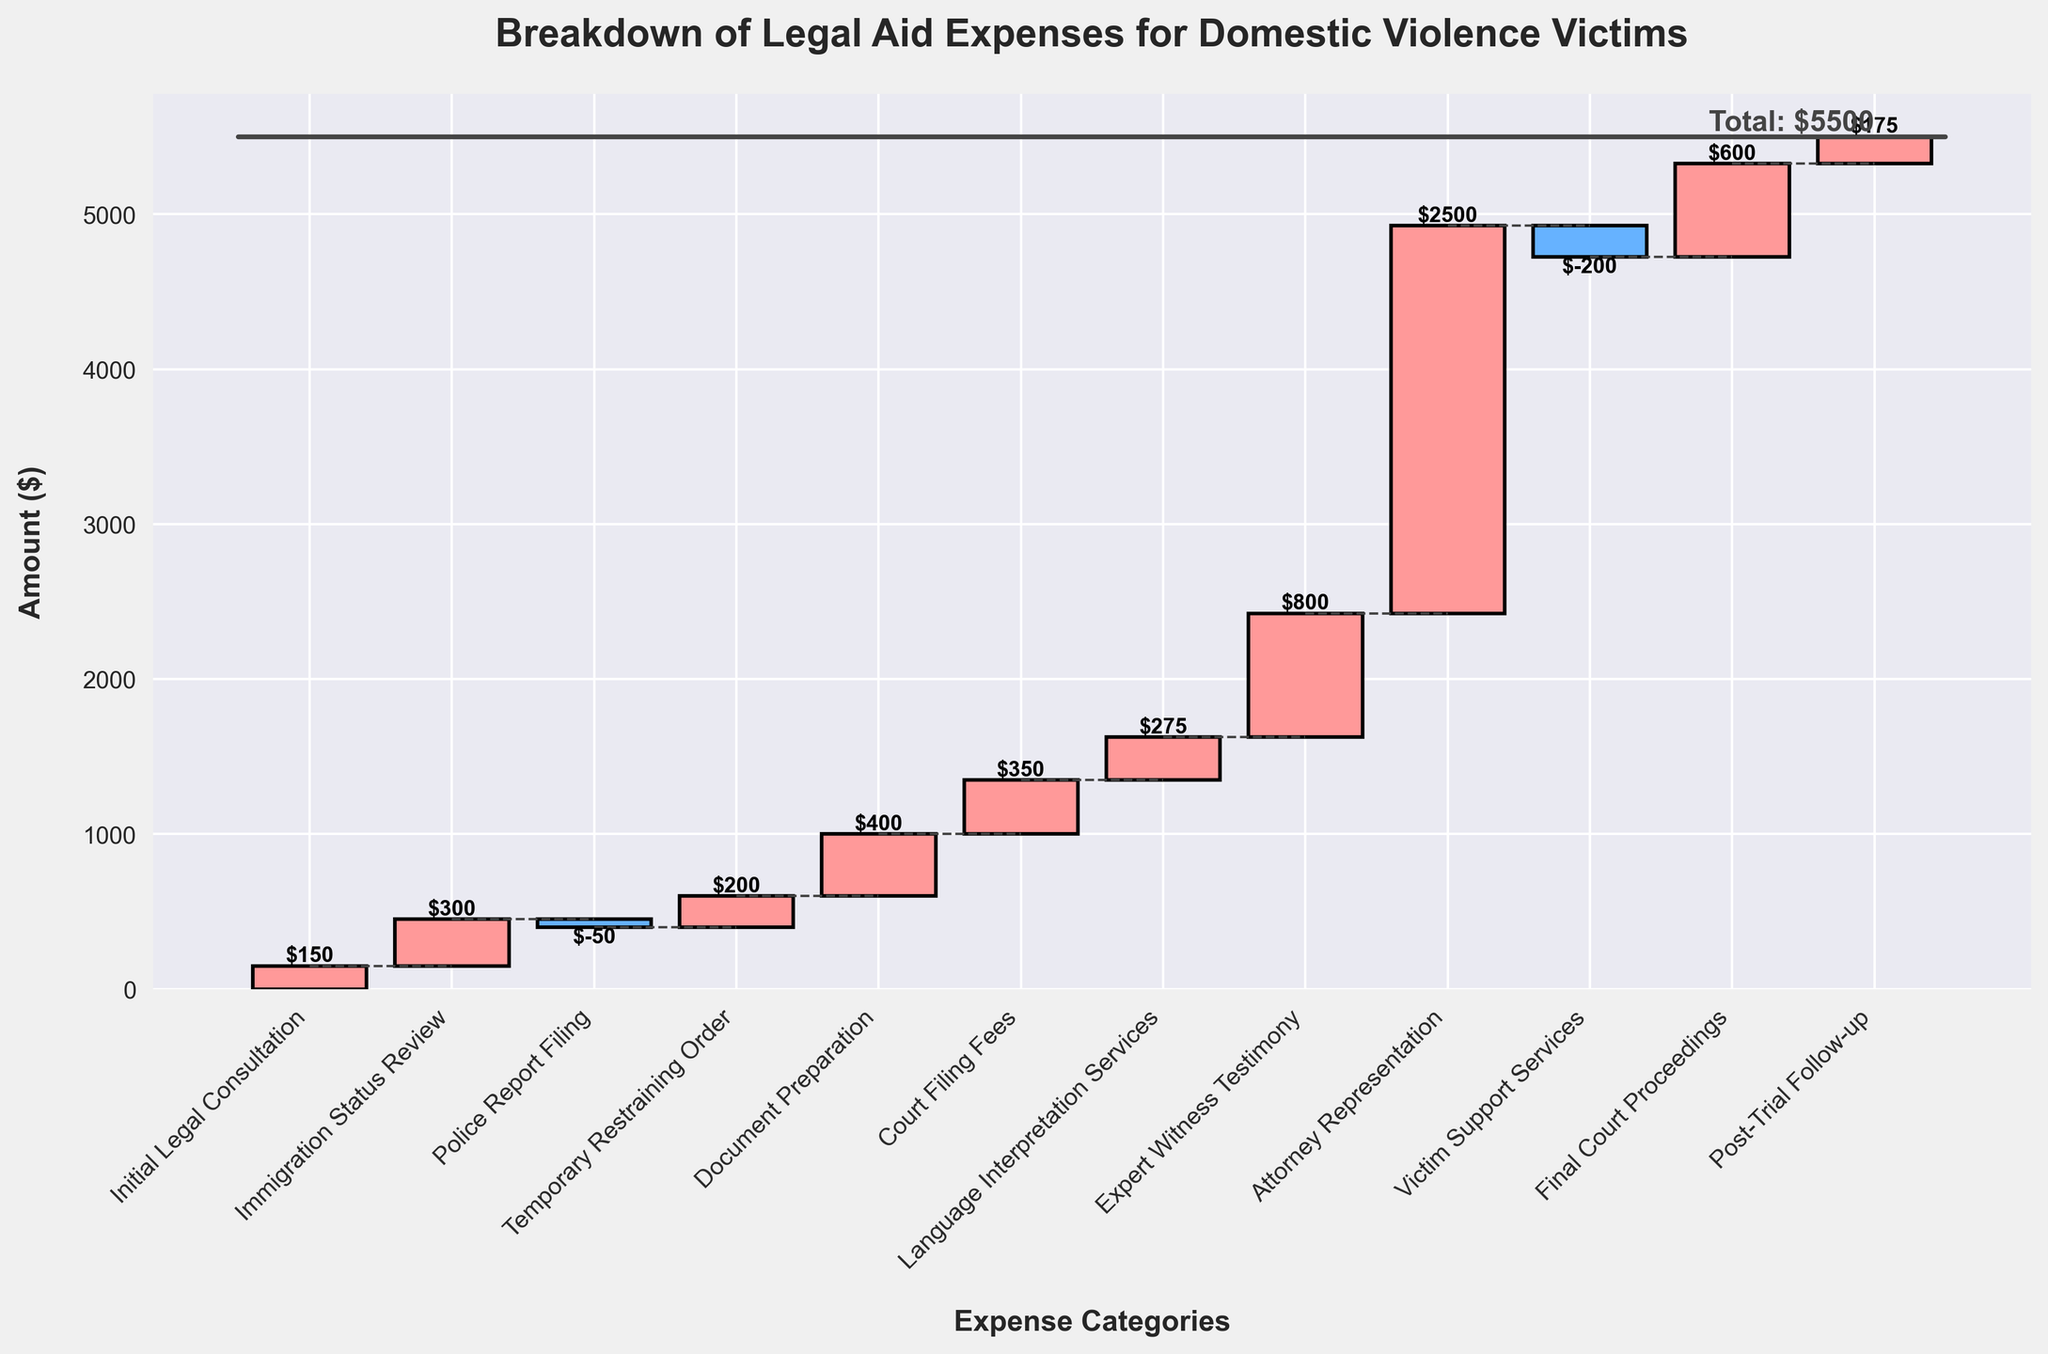What is the title of the chart? The title of the chart is located at the top and typically introduces the main subject of the visual representation. Here, the title is "Breakdown of Legal Aid Expenses for Domestic Violence Victims."
Answer: Breakdown of Legal Aid Expenses for Domestic Violence Victims How many categories of expenses are listed in the chart? The x-axis shows each category listed from "Initial Legal Consultation" to "Post-Trial Follow-up." Counting these categories gives us the total number.
Answer: 12 Which expense category has the highest cost, and what is the amount? By looking at the height of the bars, "Attorney Representation" has the tallest bar, indicating the highest cost. The label on the bar confirms this.
Answer: Attorney Representation, $2500 What is the cumulative expense after "Document Preparation"? To find the cumulative expense, add up all previous values: 150 (Initial Legal Consultation) + 300 (Immigration Status Review) - 50 (Police Report Filing) + 200 (Temporary Restraining Order) + 400 (Document Preparation).
Answer: $1000 What are the categories with deductions (negative amounts), and what are their values? Negative amounts are represented by the bars that go downward. "Police Report Filing" and "Victim Support Services" both have negative amounts.
Answer: Police Report Filing: -$50, Victim Support Services: -$200 How much is the final total expense at the end, and how is it represented in the chart? The total expense is the sum of all individual amounts, represented by the horizontal line at the end of the chart. Adding all the categories together gives the final total.
Answer: $5500 Which categories directly follow one with negative expenses? Categories after negative bars are "Temporary Restraining Order" and "Post-Trial Follow-up," which follow "Police Report Filing" and "Victim Support Services," respectively.
Answer: Temporary Restraining Order and Post-Trial Follow-up What is the difference in expenses between the "Court Filing Fees" and the "Final Court Proceedings"? Subtract the amount of "Court Filing Fees" from the amount of "Final Court Proceedings": $600 (Final Court Proceedings) - $350 (Court Filing Fees).
Answer: $250 What is the color scheme used to differentiate positive and negative values? Positive values are represented using one color, and negative values using another. By observing the chart, positive values are in a pinkish color and negative values in a bluish color.
Answer: Positive: Pink, Negative: Blue 